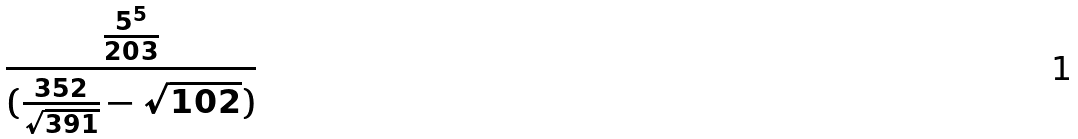<formula> <loc_0><loc_0><loc_500><loc_500>\frac { \frac { 5 ^ { 5 } } { 2 0 3 } } { ( \frac { 3 5 2 } { \sqrt { 3 9 1 } } - \sqrt { 1 0 2 } ) }</formula> 